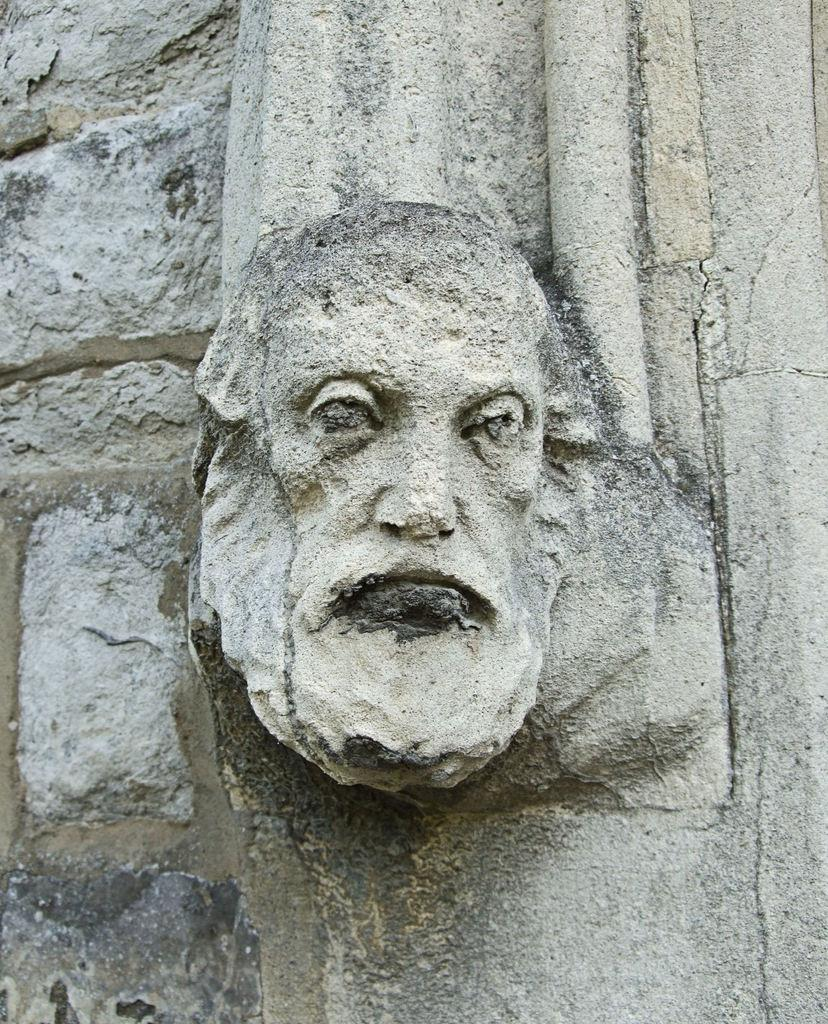What is the main subject of the image? The main subject of the image is a stone carving of a human face. Where is the stone carving located? The stone carving is on a wall. What type of lettuce is growing near the stone carving in the image? There is no lettuce present in the image; it only features a stone carving of a human face on a wall. 